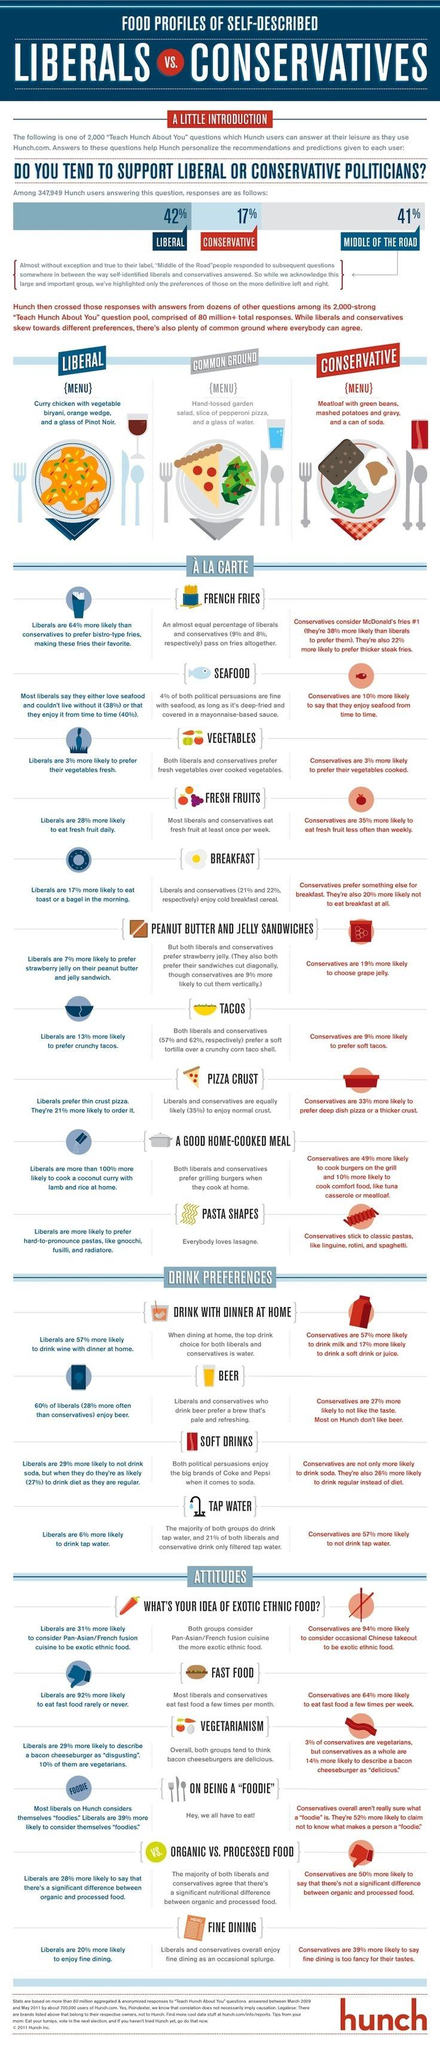Identify some key points in this picture. It is more likely that conservatives will prefer thicker steak fries than liberals. Lasagne is a type of pasta that appeals to people of all political preferences. It has been observed that conservatives are more likely to prefer deep dish pizza or a thicker crust than liberals. According to a survey, 22% of conservatives enjoy cold breakfast cereal. Liberals preferred curry chicken over meatloaf more than conservatives did. 